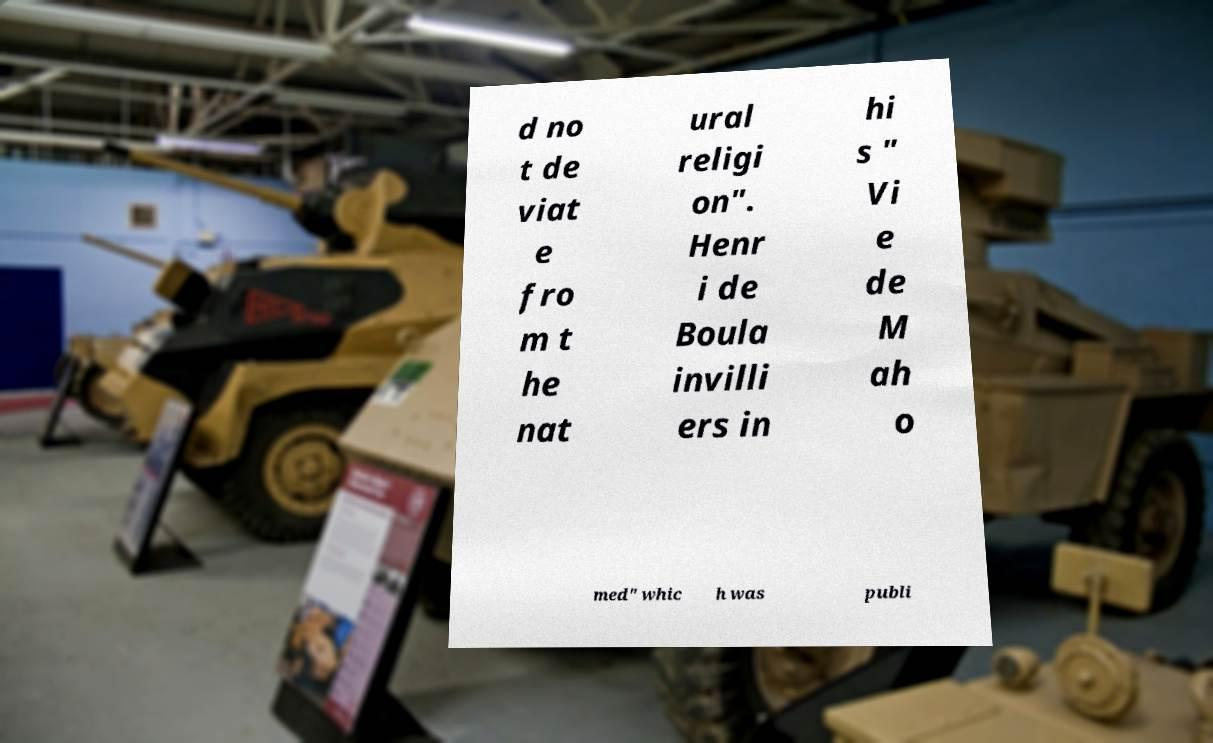I need the written content from this picture converted into text. Can you do that? d no t de viat e fro m t he nat ural religi on". Henr i de Boula invilli ers in hi s " Vi e de M ah o med" whic h was publi 